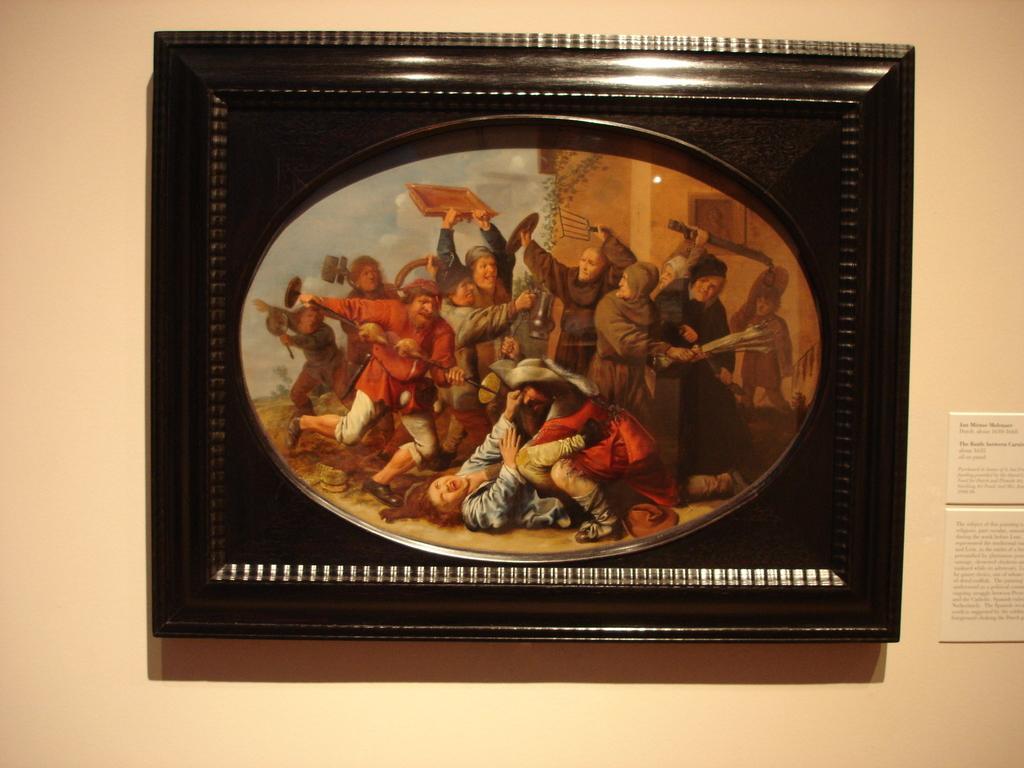Please provide a concise description of this image. In the image we can see a frame and we can see there is a picture of many people wearing clothes and they are fighting. This is a building and a cloudy sky. This is a white color wall. 